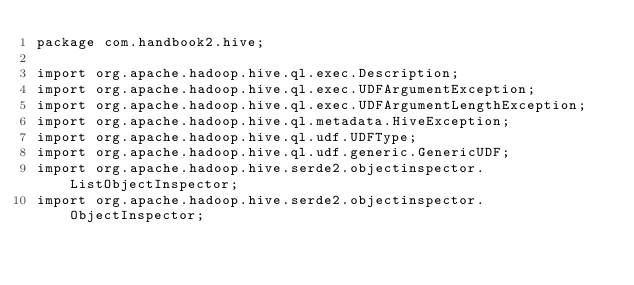<code> <loc_0><loc_0><loc_500><loc_500><_Java_>package com.handbook2.hive;

import org.apache.hadoop.hive.ql.exec.Description;
import org.apache.hadoop.hive.ql.exec.UDFArgumentException;
import org.apache.hadoop.hive.ql.exec.UDFArgumentLengthException;
import org.apache.hadoop.hive.ql.metadata.HiveException;
import org.apache.hadoop.hive.ql.udf.UDFType;
import org.apache.hadoop.hive.ql.udf.generic.GenericUDF;
import org.apache.hadoop.hive.serde2.objectinspector.ListObjectInspector;
import org.apache.hadoop.hive.serde2.objectinspector.ObjectInspector;</code> 